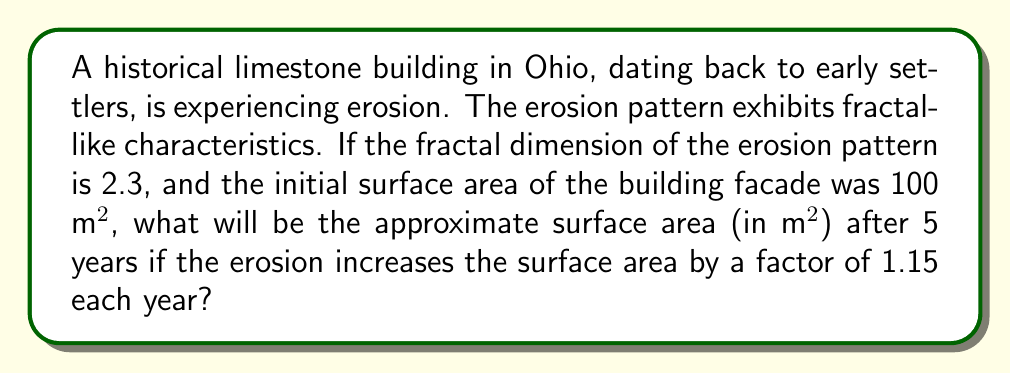Solve this math problem. To solve this problem, we'll use the concept of fractal dimension and iterative growth:

1. The fractal dimension (D) is given as 2.3, which indicates a highly irregular surface.

2. The initial surface area (A₀) is 100 m².

3. The yearly growth factor (r) is 1.15.

4. We need to calculate the area after 5 years (A₅).

5. In fractal geometry, the relationship between scale factor (s) and number of self-similar pieces (N) is given by:

   $$N = s^D$$

6. In our case, the scale factor is the yearly growth factor (r), and we're interested in the area growth over 5 years. So we can write:

   $$A_5 = A_0 \cdot r^{5D}$$

7. Substituting the values:

   $$A_5 = 100 \cdot 1.15^{5 \cdot 2.3}$$

8. Calculate the exponent:
   
   $$5 \cdot 2.3 = 11.5$$

9. Now we can calculate:

   $$A_5 = 100 \cdot 1.15^{11.5} \approx 100 \cdot 5.2047$$

10. Final calculation:

    $$A_5 \approx 520.47 \text{ m²}$$
Answer: 520.47 m² 